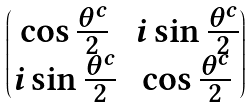Convert formula to latex. <formula><loc_0><loc_0><loc_500><loc_500>\begin{pmatrix} \cos \frac { \theta ^ { c } } { 2 } & i \sin \frac { \theta ^ { c } } { 2 } \\ i \sin \frac { \theta ^ { c } } { 2 } & \cos \frac { \theta ^ { c } } { 2 } \end{pmatrix}</formula> 